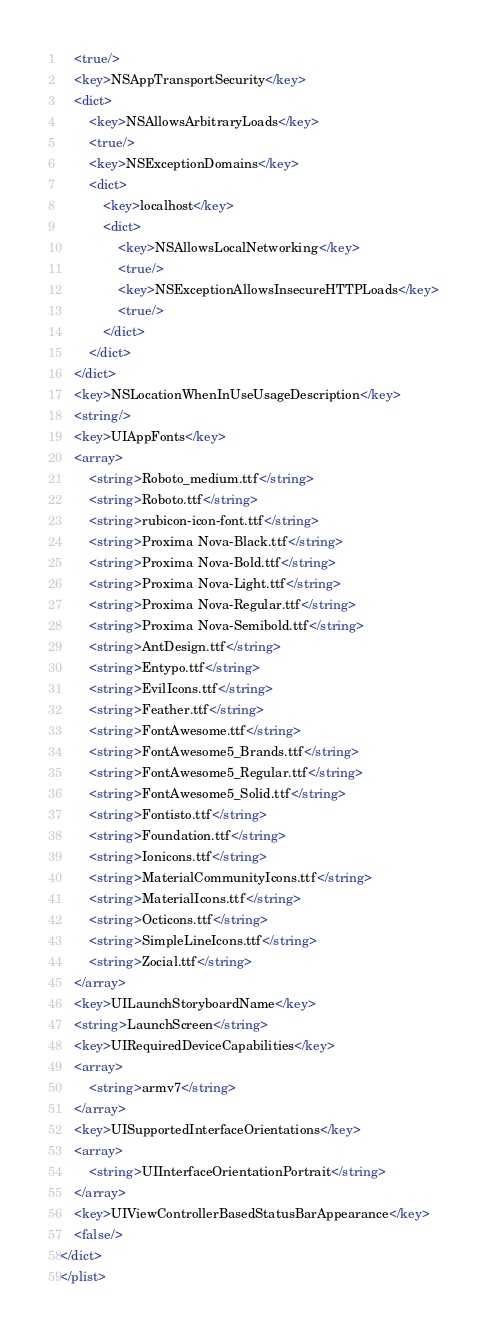<code> <loc_0><loc_0><loc_500><loc_500><_XML_>	<true/>
	<key>NSAppTransportSecurity</key>
	<dict>
		<key>NSAllowsArbitraryLoads</key>
		<true/>
		<key>NSExceptionDomains</key>
		<dict>
			<key>localhost</key>
			<dict>
				<key>NSAllowsLocalNetworking</key>
				<true/>
				<key>NSExceptionAllowsInsecureHTTPLoads</key>
				<true/>
			</dict>
		</dict>
	</dict>
	<key>NSLocationWhenInUseUsageDescription</key>
	<string/>
	<key>UIAppFonts</key>
	<array>
		<string>Roboto_medium.ttf</string>
		<string>Roboto.ttf</string>
		<string>rubicon-icon-font.ttf</string>
		<string>Proxima Nova-Black.ttf</string>
		<string>Proxima Nova-Bold.ttf</string>
		<string>Proxima Nova-Light.ttf</string>
		<string>Proxima Nova-Regular.ttf</string>
		<string>Proxima Nova-Semibold.ttf</string>
		<string>AntDesign.ttf</string>
		<string>Entypo.ttf</string>
		<string>EvilIcons.ttf</string>
		<string>Feather.ttf</string>
		<string>FontAwesome.ttf</string>
		<string>FontAwesome5_Brands.ttf</string>
		<string>FontAwesome5_Regular.ttf</string>
		<string>FontAwesome5_Solid.ttf</string>
		<string>Fontisto.ttf</string>
		<string>Foundation.ttf</string>
		<string>Ionicons.ttf</string>
		<string>MaterialCommunityIcons.ttf</string>
		<string>MaterialIcons.ttf</string>
		<string>Octicons.ttf</string>
		<string>SimpleLineIcons.ttf</string>
		<string>Zocial.ttf</string>
	</array>
	<key>UILaunchStoryboardName</key>
	<string>LaunchScreen</string>
	<key>UIRequiredDeviceCapabilities</key>
	<array>
		<string>armv7</string>
	</array>
	<key>UISupportedInterfaceOrientations</key>
	<array>
		<string>UIInterfaceOrientationPortrait</string>
	</array>
	<key>UIViewControllerBasedStatusBarAppearance</key>
	<false/>
</dict>
</plist>
</code> 